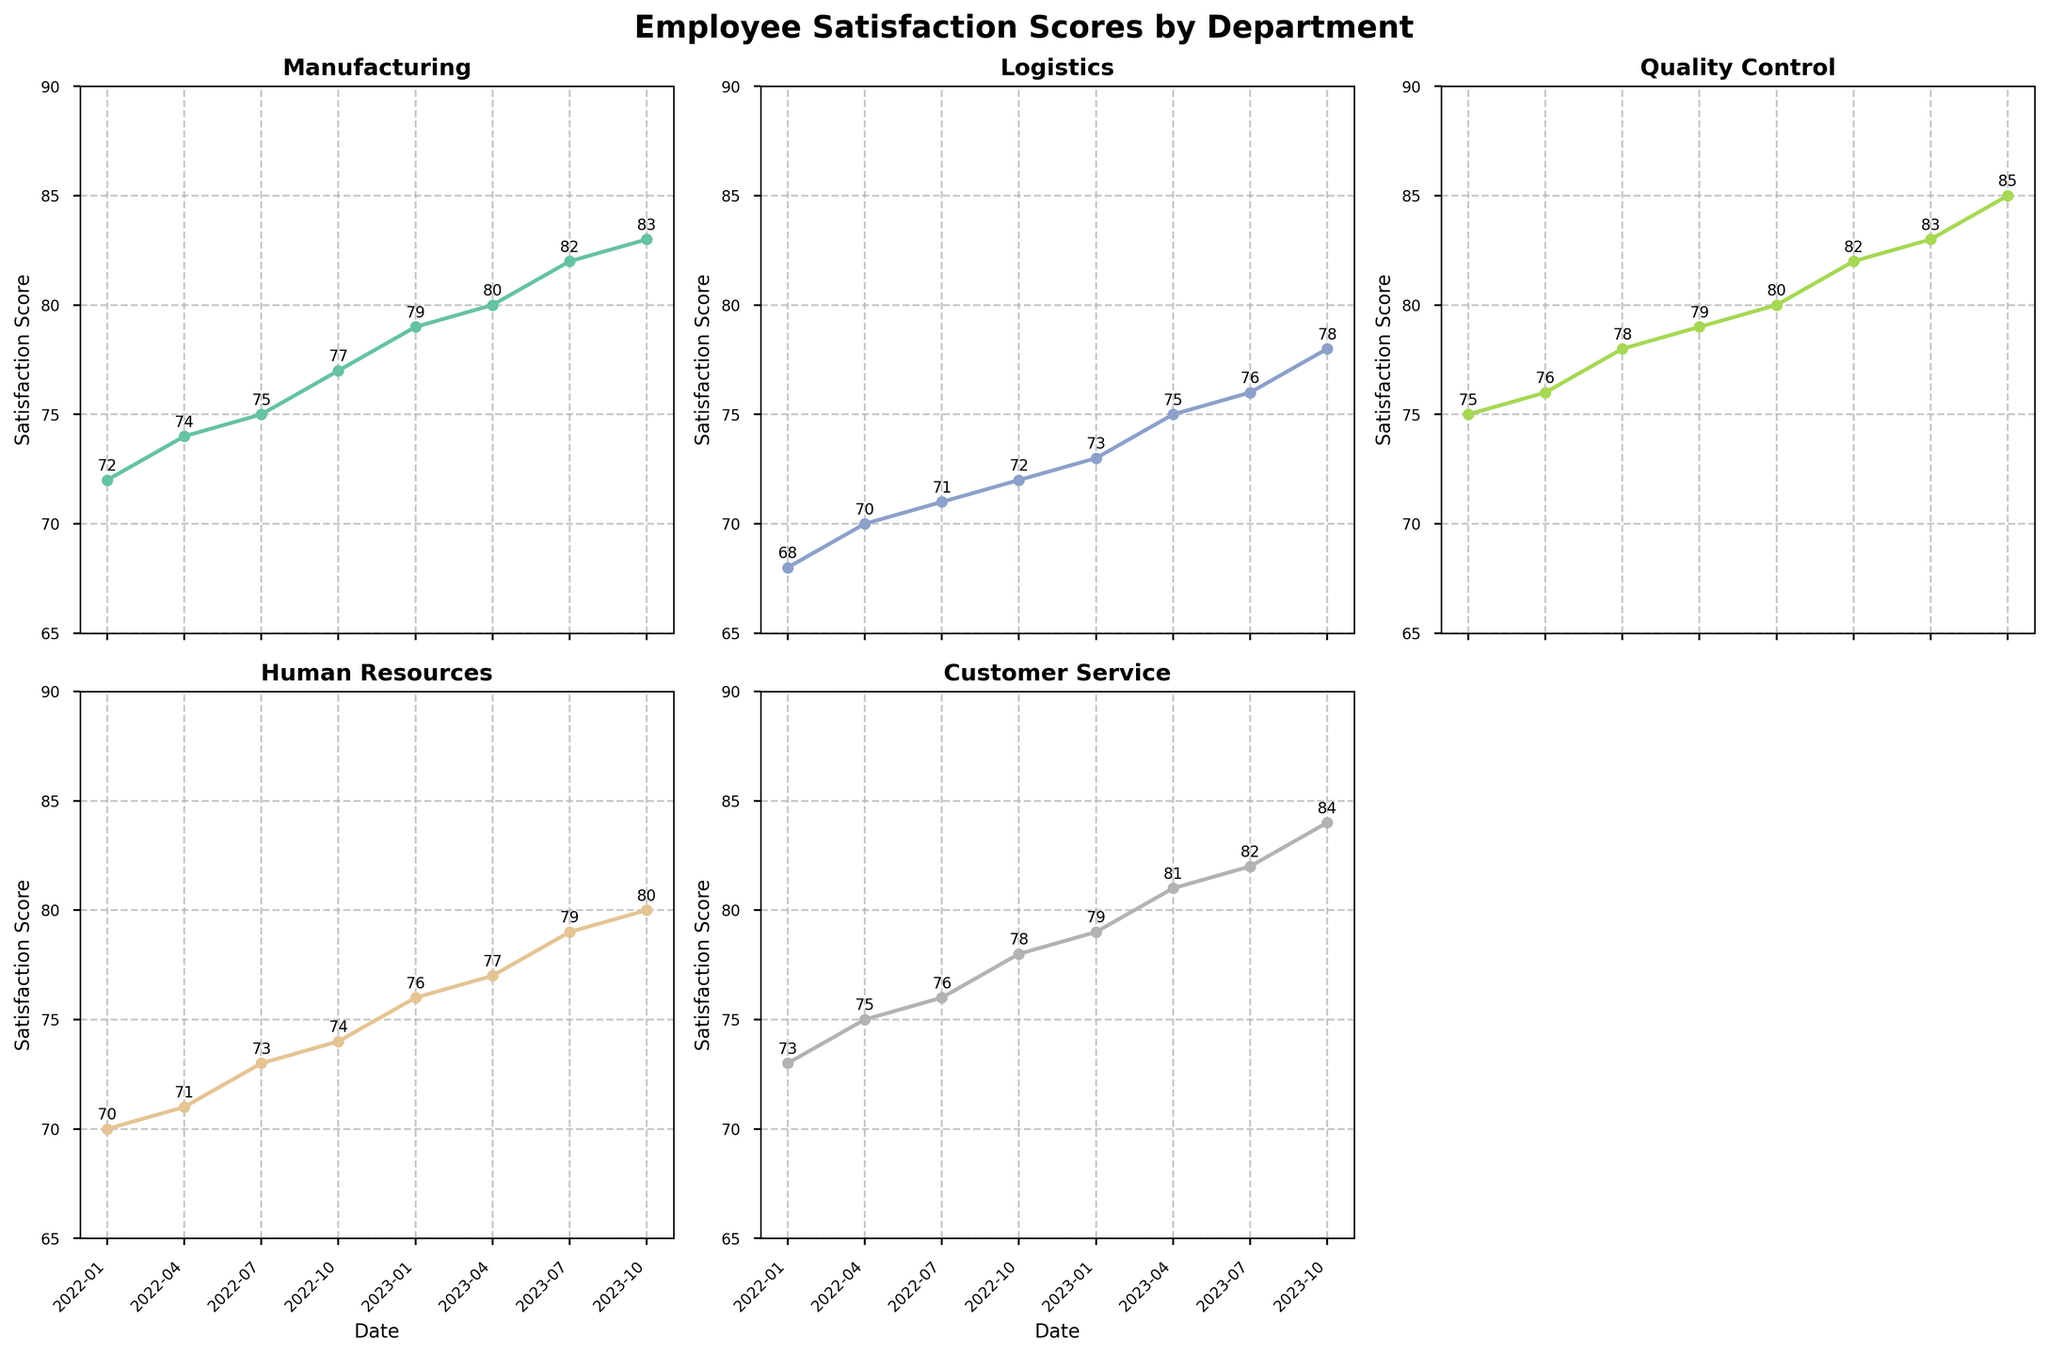What is the title of the subplot? The title is displayed on the top of the figure and reads 'Employee Satisfaction Scores by Department'.
Answer: Employee Satisfaction Scores by Department Which department has the highest satisfaction score in October 2023? Checking the figure for October 2023, the highest score is in the Quality Control department with a score of 85.
Answer: Quality Control How many departments are visualized in the plots? The figure visualizes satisfaction scores for five departments, with one subplot removed.
Answer: Five What are the x-axis labels for the plots? The x-axis labels show the dates: '2022-01', '2022-04', '2022-07', '2022-10', '2023-01', '2023-04', '2023-07', and '2023-10'.
Answer: '2022-01', '2022-04', '2022-07', '2022-10', '2023-01', '2023-04', '2023-07', '2023-10' Which department shows the largest increase in satisfaction score from January 2022 to October 2023? Calculating the difference between the scores in January 2022 and October 2023 for each department, Quality Control shows the largest increase (85 - 75 = 10).
Answer: Quality Control What was Manufacturing's satisfaction score in April 2023? Checking the subplot for Manufacturing in April 2023, the satisfaction score is 80.
Answer: 80 Between which two consecutive dates did Logistics see the highest growth in satisfaction scores? Checking the growth between each consecutive date for Logistics, the highest increase is between July 2023 and October 2023 (78 - 76 = 2).
Answer: July 2023 to October 2023 What is Customer Service's average satisfaction score from January 2022 to October 2023? Summing up Customer Service’s scores (73 + 75 + 76 + 78 + 79 + 81 + 82 + 84) and dividing by 8 gives an average of 78.5.
Answer: 78.5 Which department had the lowest satisfaction score in January 2022 and what was it? Checking January 2022's scores, Logistics had the lowest score with 68.
Answer: Logistics, 68 What is the range (difference between the highest and lowest scores) of Human Resources' satisfaction scores over the entire period? The highest score for Human Resources over the period is 80, and the lowest is 70. The range is 80 - 70 = 10.
Answer: 10 